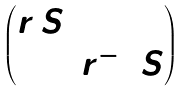<formula> <loc_0><loc_0><loc_500><loc_500>\begin{pmatrix} r \, S & 0 \\ 0 & r ^ { - 1 } \, S \end{pmatrix}</formula> 